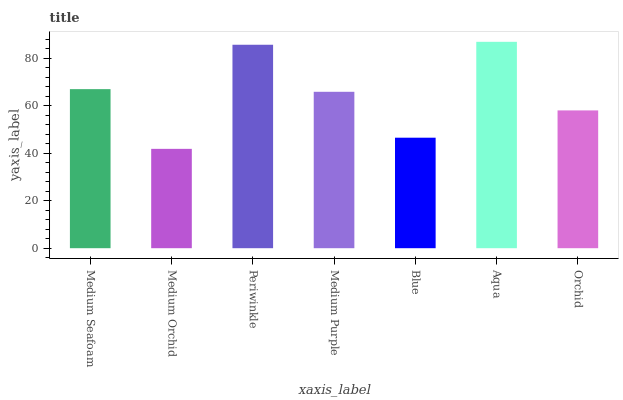Is Periwinkle the minimum?
Answer yes or no. No. Is Periwinkle the maximum?
Answer yes or no. No. Is Periwinkle greater than Medium Orchid?
Answer yes or no. Yes. Is Medium Orchid less than Periwinkle?
Answer yes or no. Yes. Is Medium Orchid greater than Periwinkle?
Answer yes or no. No. Is Periwinkle less than Medium Orchid?
Answer yes or no. No. Is Medium Purple the high median?
Answer yes or no. Yes. Is Medium Purple the low median?
Answer yes or no. Yes. Is Aqua the high median?
Answer yes or no. No. Is Orchid the low median?
Answer yes or no. No. 